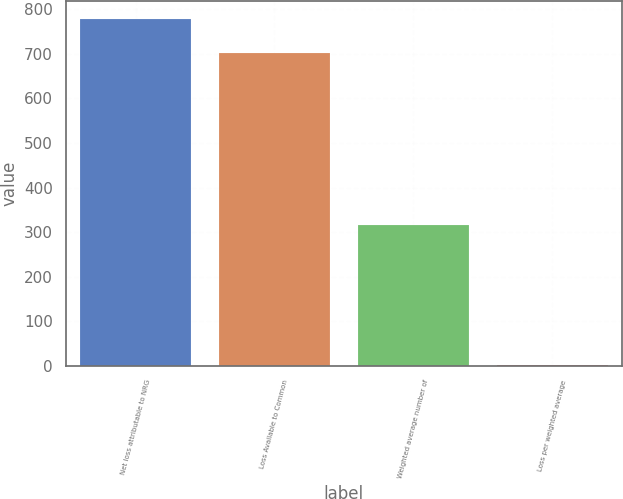Convert chart. <chart><loc_0><loc_0><loc_500><loc_500><bar_chart><fcel>Net loss attributable to NRG<fcel>Loss Available to Common<fcel>Weighted average number of<fcel>Loss per weighted average<nl><fcel>778.18<fcel>701<fcel>316<fcel>2.22<nl></chart> 